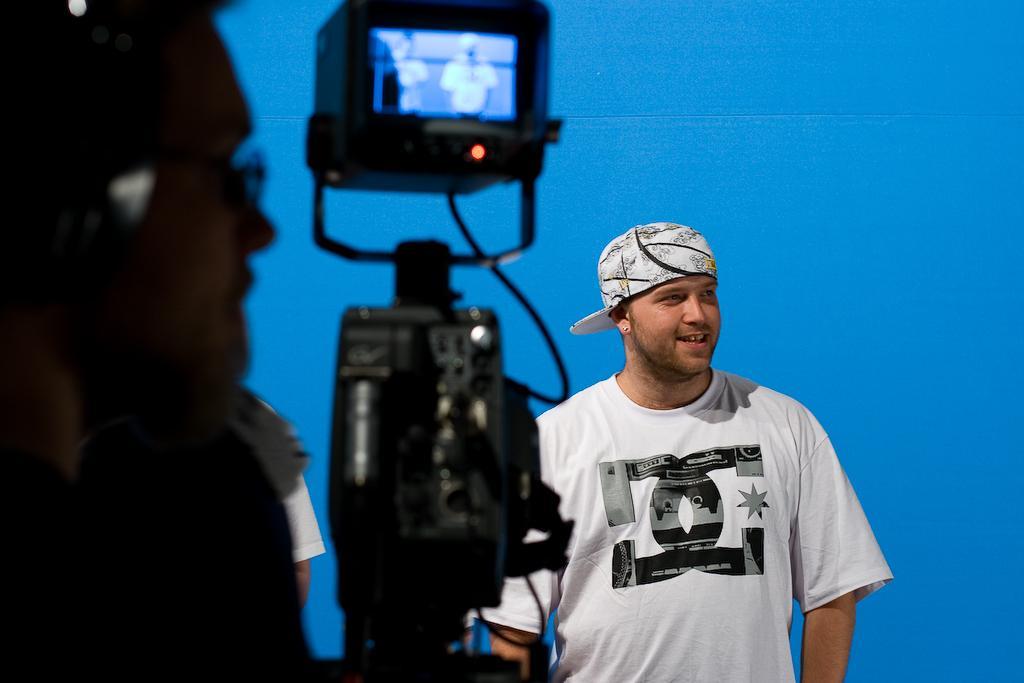Please provide a concise description of this image. In front of the picture, we see a camera stand. On the left side, we see the man is wearing the spectacles. In the middle of the picture, we see the man in white T-shirt is standing. He is wearing a cap and he is smiling. In the background, it is blue in color. 